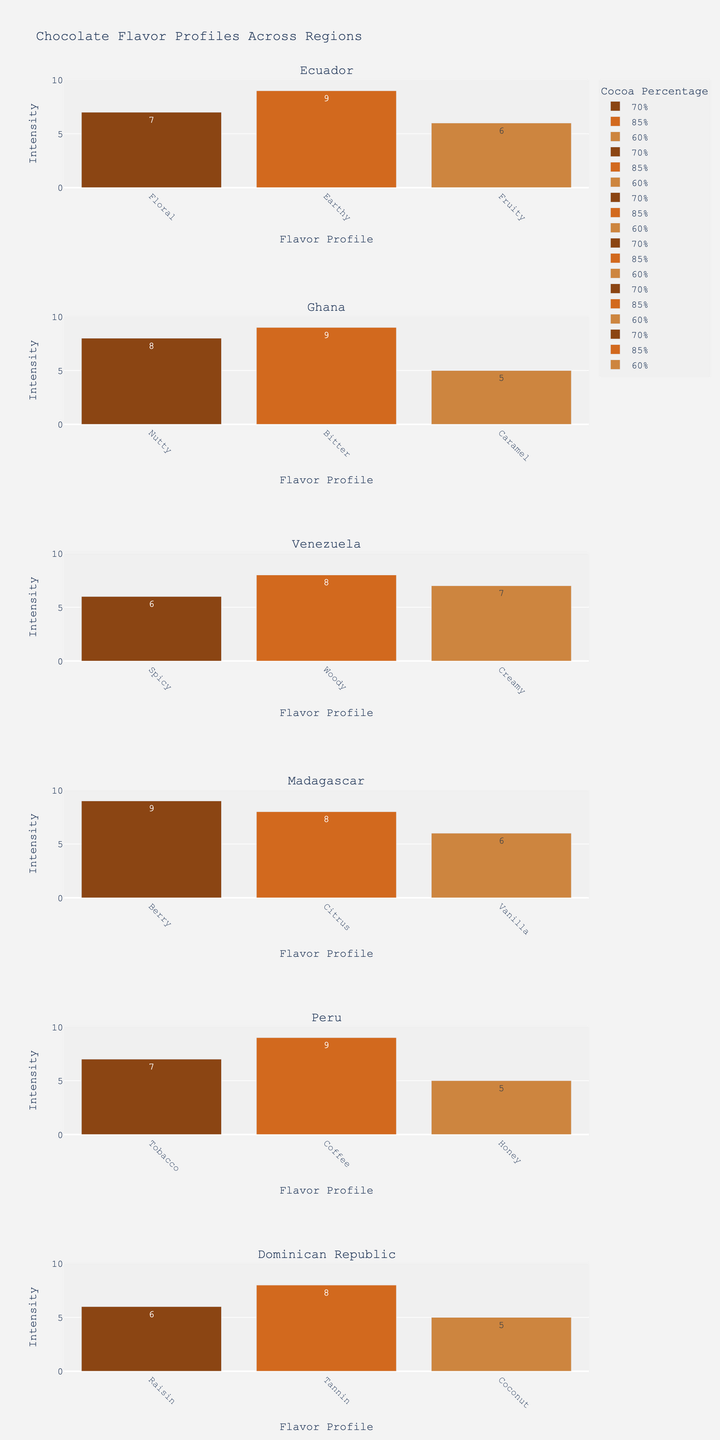What is the title of the figure? The title is usually prominently displayed at the top of the plot.
Answer: Chocolate Flavor Profiles Across Regions How many regions are represented in the figure? Count the number of distinct subplot titles, each representing a different region.
Answer: 6 Which region has the highest intensity for the 85% cocoa percentage? Look at the bars marked 85% across the subplots and identify the one with the tallest bar.
Answer: Peru Which flavor profile in Ecuador has the highest intensity? Check the bars in Ecuador's subplot and identify the tallest bar.
Answer: Earthy How many different cocoa percentages are presented in each subplot? Count the number of cocoa percentages listed in any single subplot, as they are consistent across regions.
Answer: 3 What is the total intensity for all flavor profiles in Madagascar for the 70% cocoa percentage? Add the intensities of all bars in Madagascar's subplot for the 70% cocoa percentage.
Answer: 9 (Berry) How does the intensity of the Fruity flavor in Ecuador compare to the intensity of the Vanilla flavor in Madagascar? Look at the heights of the Fruity bar in Ecuador's subplot and the Vanilla bar in Madagascar's subplot, then compare them.
Answer: Fruity is taller (6 vs 6) What is the range of intensities depicted in the figure? Identify the smallest and largest numbers on the y-axis across all subplots.
Answer: 0 to 9 Which region has the most varied flavor profiles based on the number of different flavors shown? Count the distinct flavor profiles in each region's subplot and identify the region with the most.
Answer: It is evenly distributed across all regions with 3 different flavors each Is there any region where the intensity is the same across all percentages of cocoa content? Compare the bars' heights for each percentage of cocoa content within every region's subplot.
Answer: No 